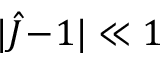Convert formula to latex. <formula><loc_0><loc_0><loc_500><loc_500>| \hat { J } \, - \, 1 | \ll 1</formula> 